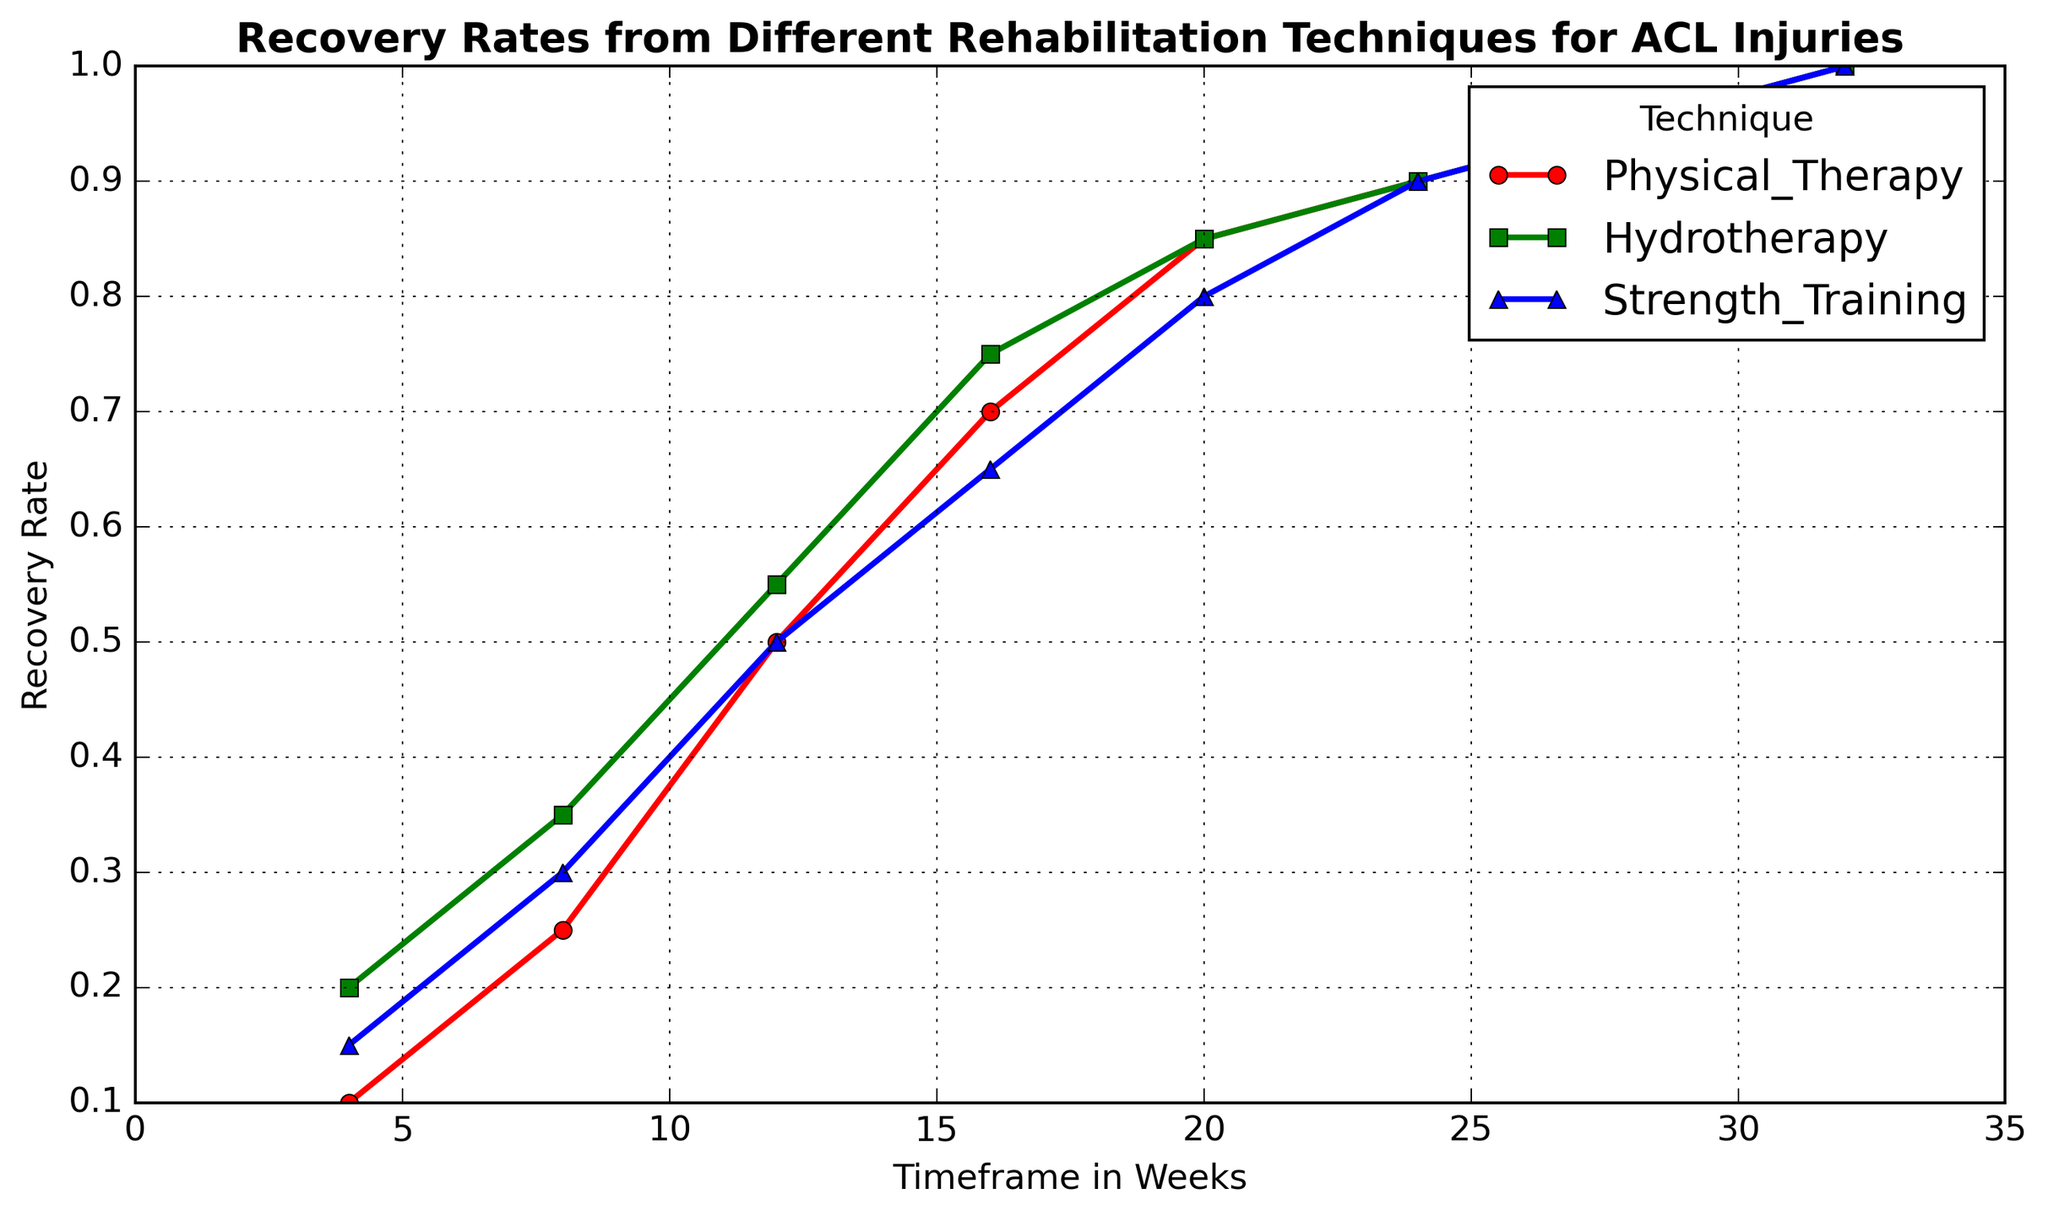Which technique has the highest recovery rate at 4 weeks? To determine the highest recovery rate at 4 weeks, I compare the values for that timeframe: Physical Therapy (0.1), Hydrotherapy (0.2), and Strength Training (0.15). Hydrotherapy has the highest rate.
Answer: Hydrotherapy At what point do all techniques reach a 90% recovery rate? Each technique reaches 90% recovery rate at different points: Physical Therapy at 24 weeks, Hydrotherapy at 24 weeks, and Strength Training at 24 weeks.
Answer: 24 weeks Which technique consistently shows a higher recovery rate throughout, Hydrotherapy or Strength Training? Comparing the recovery rates for each timeframe for Hydrotherapy and Strength Training: Hydrotherapy 0.2 > 0.15, 0.35 > 0.3, 0.55 > 0.5, 0.75 > 0.65, similar or overlapping from 20 weeks onwards. Hydrotherapy consistently shows a higher recovery rate until 20 weeks.
Answer: Hydrotherapy What is the difference in recovery rate between Hydrotherapy and Physical Therapy at 16 weeks? At 16 weeks, Hydrotherapy has a recovery rate of 0.75 and Physical Therapy has 0.7. The difference is 0.75 - 0.7 = 0.05.
Answer: 0.05 Which technique reaches a 50% recovery rate the earliest, and at what week is it? Looking at when each technique reaches at least 0.5: Physical Therapy at 12 weeks, Hydrotherapy at 12 weeks, Strength Training at 12 weeks. All techniques reach 50% at the same week.
Answer: 12 weeks How does the recovery rate for Strength Training at 24 weeks compare to Physical Therapy at the same timeframe? At 24 weeks, both Physical Therapy and Strength Training have a recovery rate of 0.9, so their recovery rates are equal.
Answer: Equal Between 8 and 16 weeks, which technique shows the greatest improvement in recovery rate and what is the improvement? Calculating the improvement for each technique:
- Physical Therapy: 0.7 - 0.25 = 0.45
- Hydrotherapy: 0.75 - 0.35 = 0.4
- Strength Training: 0.65 - 0.3 = 0.35
Physical Therapy shows the greatest improvement.
Answer: 0.45 What is the cumulative recovery rate increase for Hydrotherapy from 4 to 32 weeks? Adding the recovery rate increase at each timeframe:
(0.35 - 0.2) + (0.55 - 0.35) + (0.75 - 0.55) + (0.85 - 0.75) + (0.9 - 0.85) + (0.95 - 0.9) + (1.0 - 0.95) = 0.15 + 0.2 + 0.2 + 0.1 + 0.05 + 0.05 + 0.05 = 0.80.
Answer: 0.80 From 8 to 32 weeks, which technique shows the least improvement in recovery rate and what is the improvement? Calculating the improvement for each technique from 8 to 32 weeks:
- Physical Therapy: 1.0 - 0.25 = 0.75
- Hydrotherapy: 1.0 - 0.35 = 0.65
- Strength Training: 1.0 - 0.3 = 0.7
Hydrotherapy shows the least improvement.
Answer: 0.65 